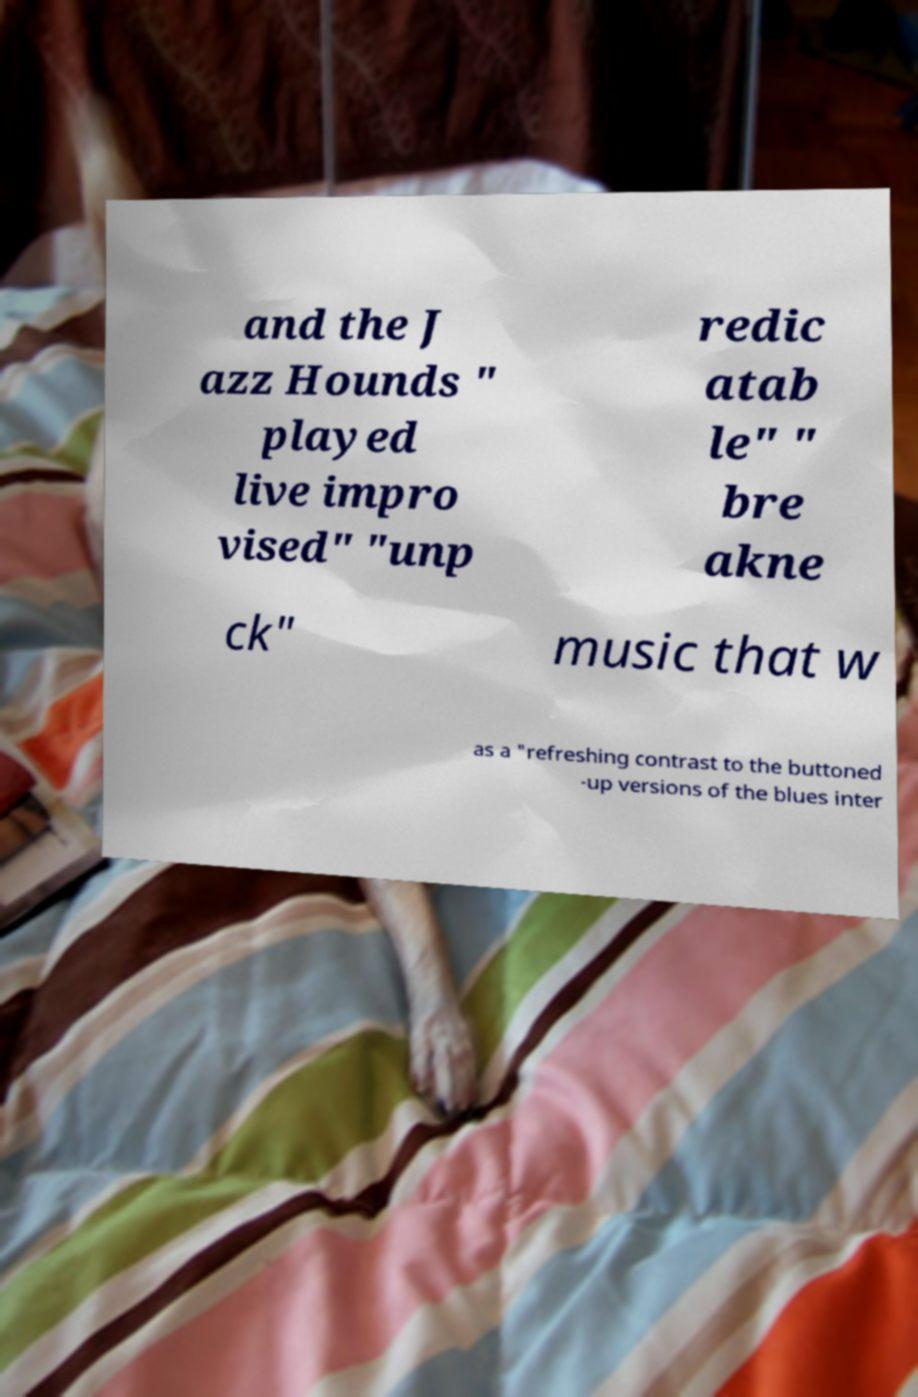What messages or text are displayed in this image? I need them in a readable, typed format. and the J azz Hounds " played live impro vised" "unp redic atab le" " bre akne ck" music that w as a "refreshing contrast to the buttoned -up versions of the blues inter 